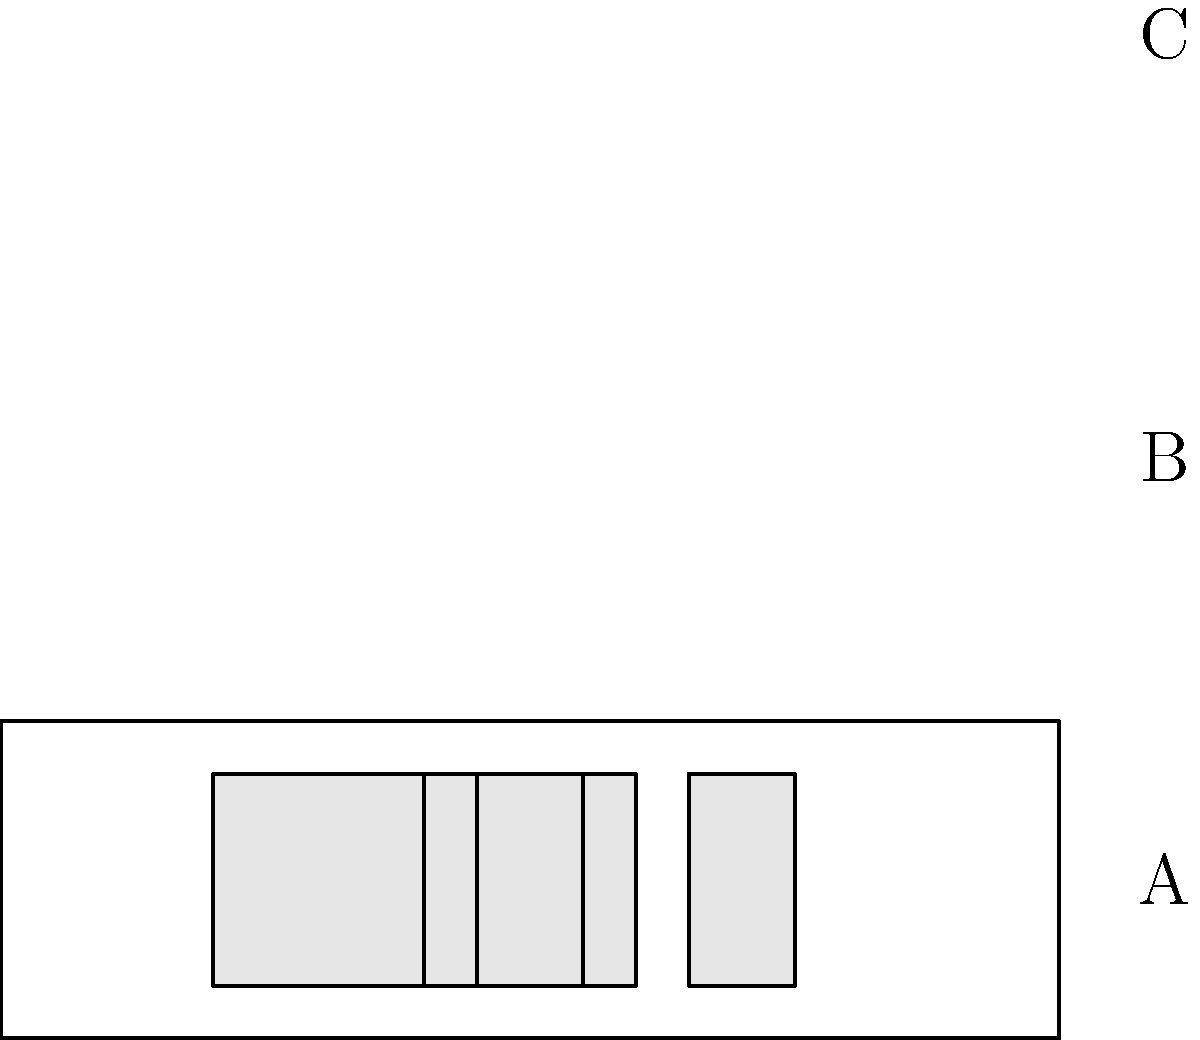Identify the pickup configuration labeled 'C' in the diagram, which is commonly associated with John Frusciante's guitar setup in many Red Hot Chili Peppers recordings. To identify the pickup configuration labeled 'C', let's analyze each configuration step-by-step:

1. Configuration A: This shows a single rectangular shape in the center, representing a single pickup. This is likely a single-coil pickup.

2. Configuration B: This shows a wider rectangular shape in the center, which is typically representative of a humbucker pickup.

3. Configuration C: This configuration shows three pickups:
   - The leftmost pickup (closest to the neck) is wider, indicating a humbucker.
   - The middle and bridge pickups are narrower, indicating single-coil pickups.

This arrangement of a humbucker followed by two single-coil pickups is known as an HSS configuration (Humbucker-Single-Single).

John Frusciante, especially during his time with the Red Hot Chili Peppers, is known for often using Fender Stratocasters with an HSS configuration. This setup allows for a variety of tones, from the warmer, fuller sound of the humbucker to the brighter, clearer tones of the single-coils, which is characteristic of Frusciante's versatile playing style.
Answer: HSS (Humbucker-Single-Single) 